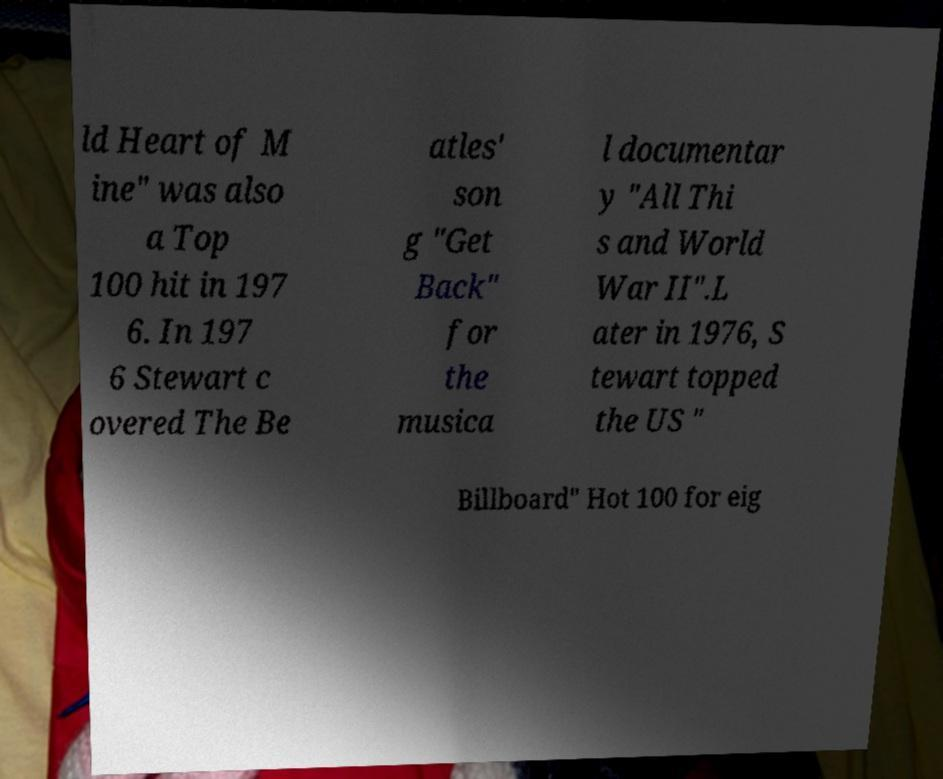Please read and relay the text visible in this image. What does it say? ld Heart of M ine" was also a Top 100 hit in 197 6. In 197 6 Stewart c overed The Be atles' son g "Get Back" for the musica l documentar y "All Thi s and World War II".L ater in 1976, S tewart topped the US " Billboard" Hot 100 for eig 